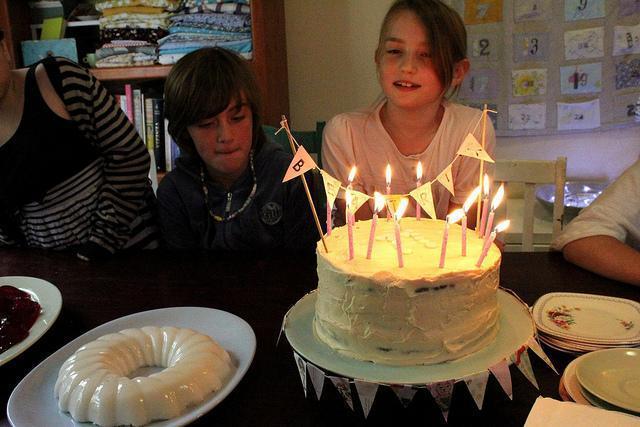How many pieces is the cake cut into?
Give a very brief answer. 0. How many cakes in the shot?
Give a very brief answer. 1. How many cakes are there?
Give a very brief answer. 2. How many people are in the picture?
Give a very brief answer. 4. 